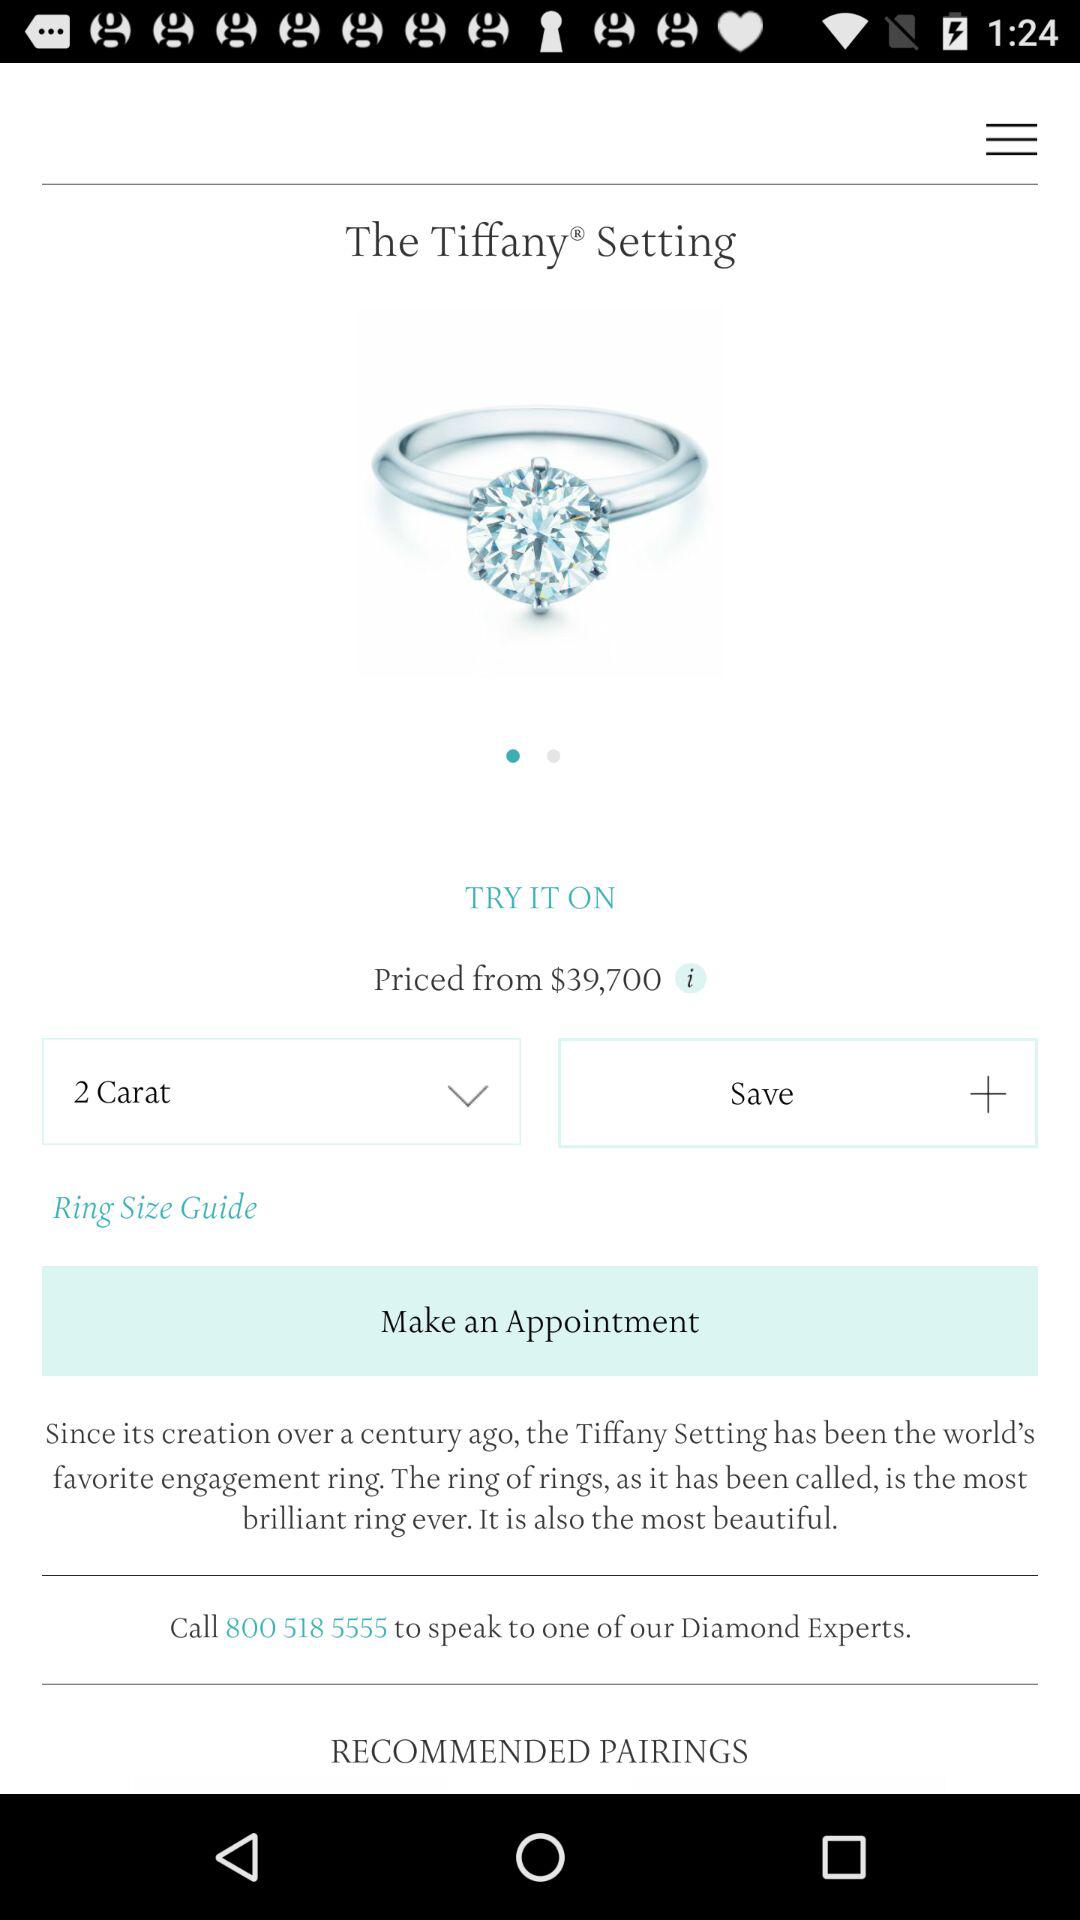What is the price of the ring? The price is $39,700. 